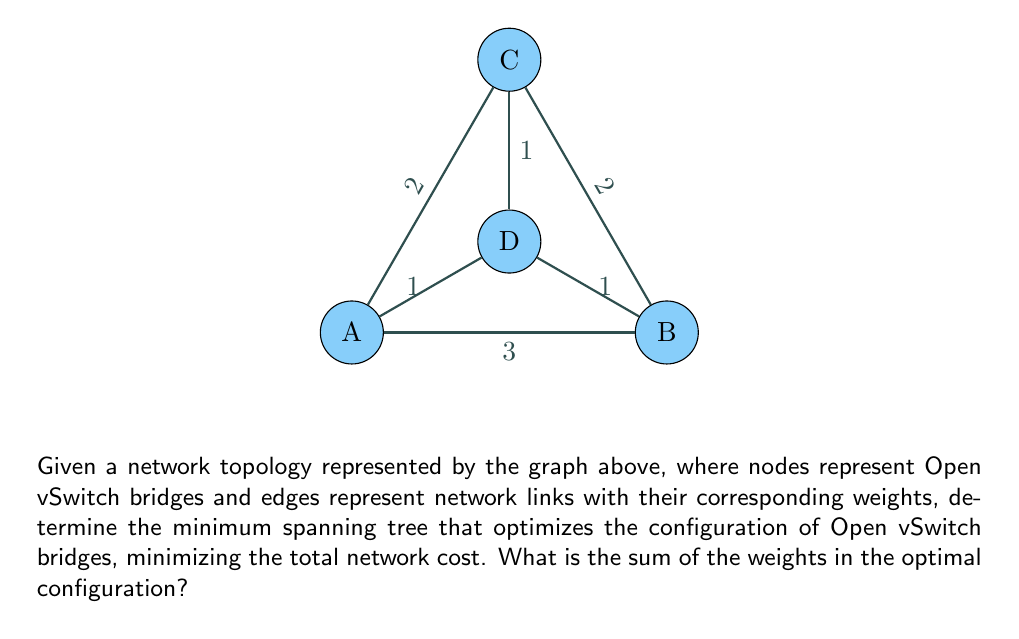Teach me how to tackle this problem. To solve this problem, we'll use Kruskal's algorithm to find the minimum spanning tree (MST) of the given graph. This will provide the optimal configuration of Open vSwitch bridges with the minimum total network cost.

Step 1: Sort the edges by weight in ascending order:
1. (A,D), (B,D), (C,D) - weight 1
2. (A,C), (B,C) - weight 2
3. (A,B) - weight 3

Step 2: Apply Kruskal's algorithm:
1. Add (A,D) to the MST
2. Add (B,D) to the MST
3. Add (C,D) to the MST

At this point, we have connected all nodes with the minimum possible weight. The algorithm stops here as adding any more edges would create a cycle.

Step 3: Calculate the total weight of the MST:
$$ \text{Total Weight} = w(A,D) + w(B,D) + w(C,D) = 1 + 1 + 1 = 3 $$

The resulting minimum spanning tree represents the optimal configuration of Open vSwitch bridges, minimizing the total network cost while ensuring all nodes are connected.
Answer: 3 